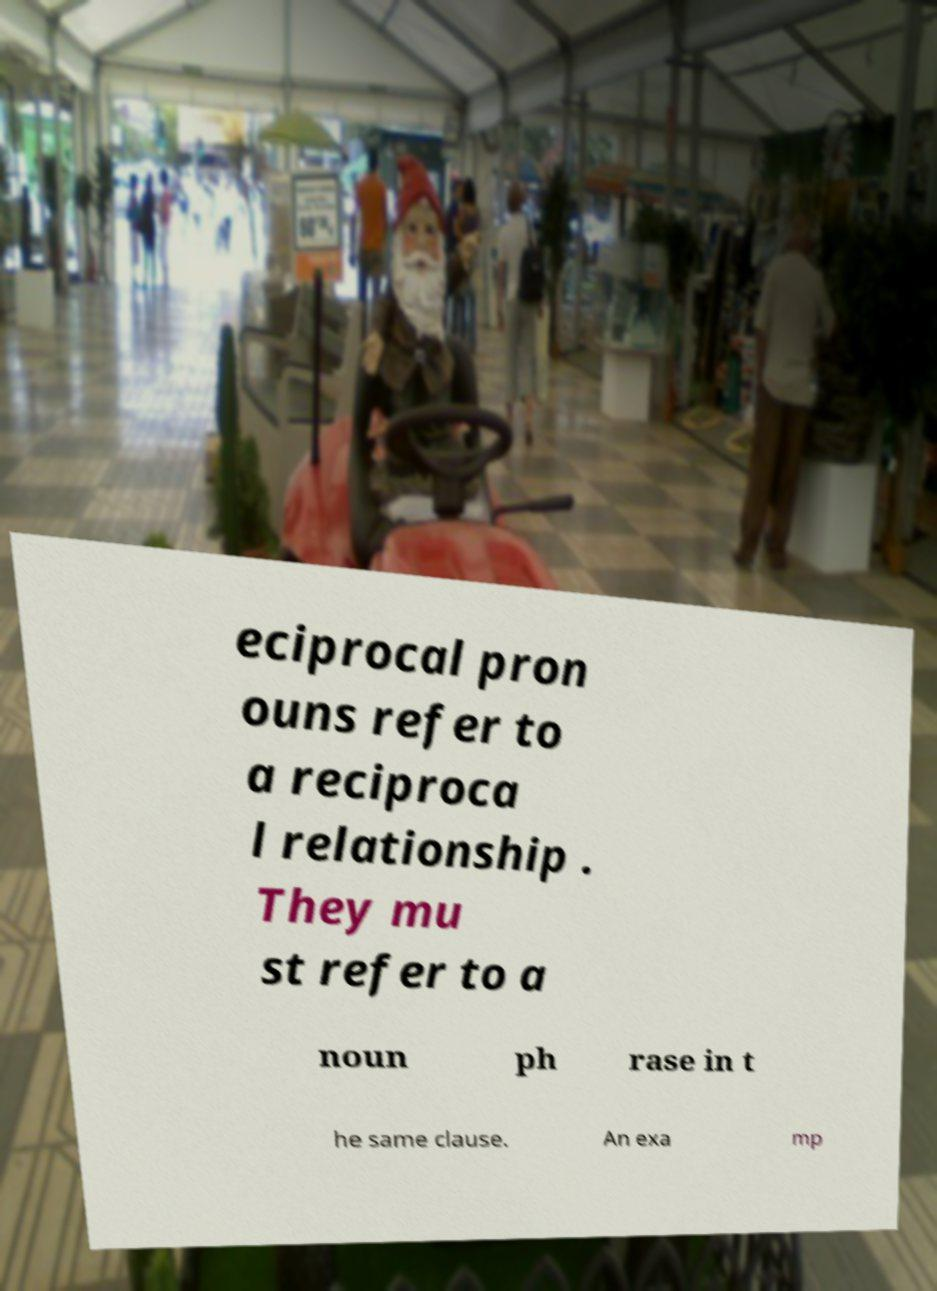What messages or text are displayed in this image? I need them in a readable, typed format. eciprocal pron ouns refer to a reciproca l relationship . They mu st refer to a noun ph rase in t he same clause. An exa mp 